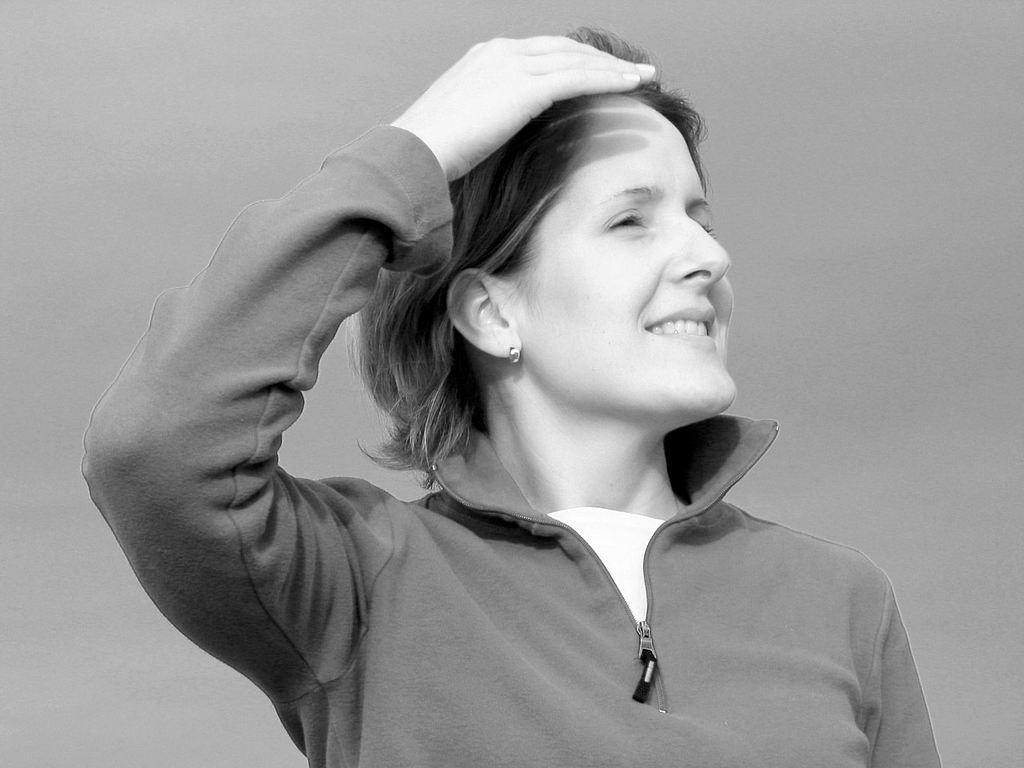What is the color scheme of the image? The image is black and white. Who is present in the image? There is a woman in the image. What is the woman doing in the image? The woman is standing and smiling. What type of clothing is the woman wearing? The woman is wearing a jerkin. Can you see any boats in the harbor in the image? There is no harbor or boats present in the image; it features a woman standing and smiling in a black and white setting. 